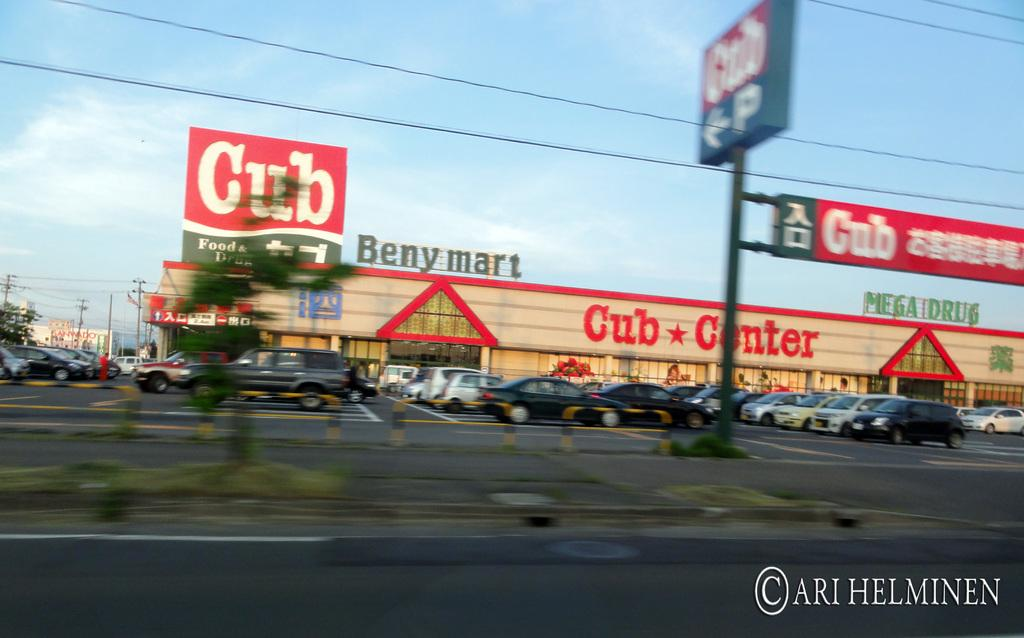<image>
Offer a succinct explanation of the picture presented. A store that is name Cub center and its car park. 